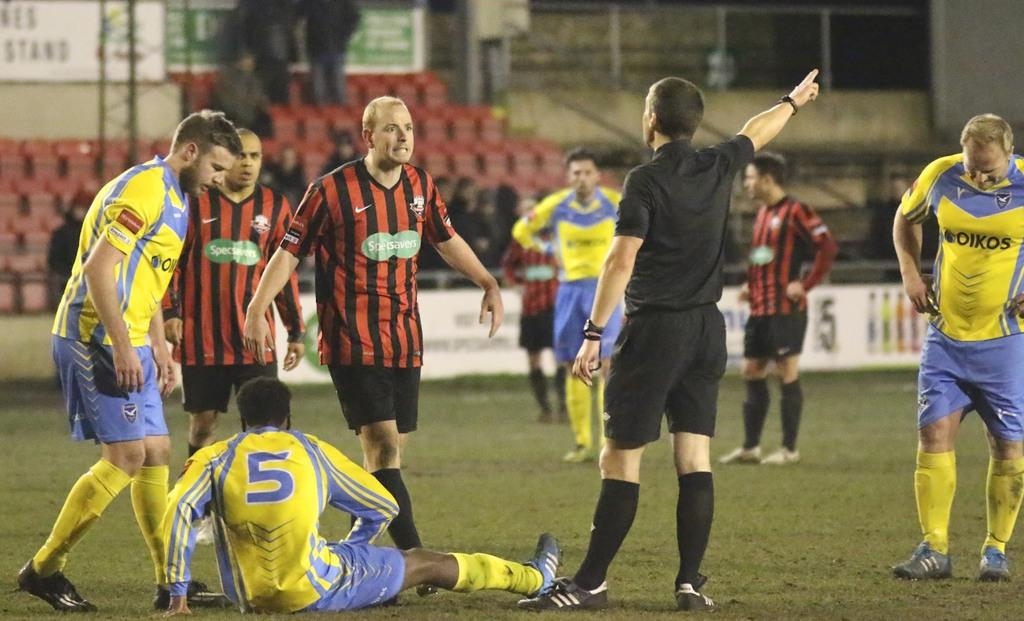<image>
Create a compact narrative representing the image presented. A player in a yellow jersey with a 5 on it is injured on the field of a soccer game and surrounded by other players. 